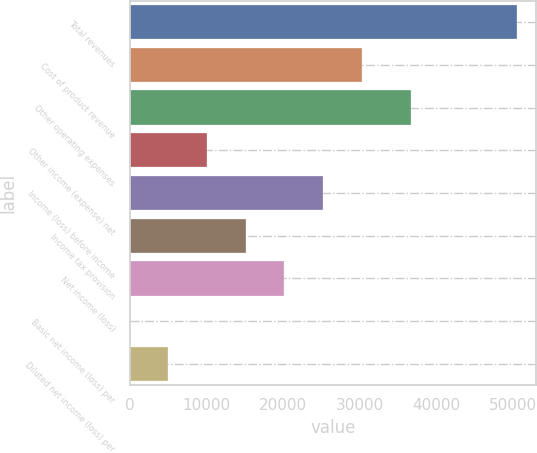<chart> <loc_0><loc_0><loc_500><loc_500><bar_chart><fcel>Total revenues<fcel>Cost of product revenue<fcel>Other operating expenses<fcel>Other income (expense) net<fcel>Income (loss) before income<fcel>Income tax provision<fcel>Net income (loss)<fcel>Basic net income (loss) per<fcel>Diluted net income (loss) per<nl><fcel>50433<fcel>30259.8<fcel>36641<fcel>10086.7<fcel>25216.5<fcel>15130<fcel>20173.2<fcel>0.09<fcel>5043.38<nl></chart> 